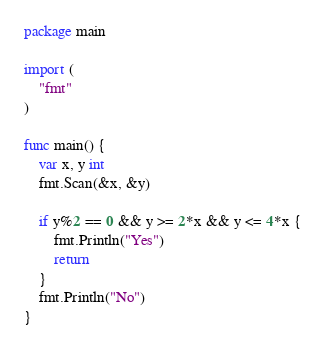Convert code to text. <code><loc_0><loc_0><loc_500><loc_500><_Go_>package main

import (
	"fmt"
)

func main() {
	var x, y int
	fmt.Scan(&x, &y)
  
	if y%2 == 0 && y >= 2*x && y <= 4*x {
		fmt.Println("Yes")
		return
	}
	fmt.Println("No")
}
</code> 